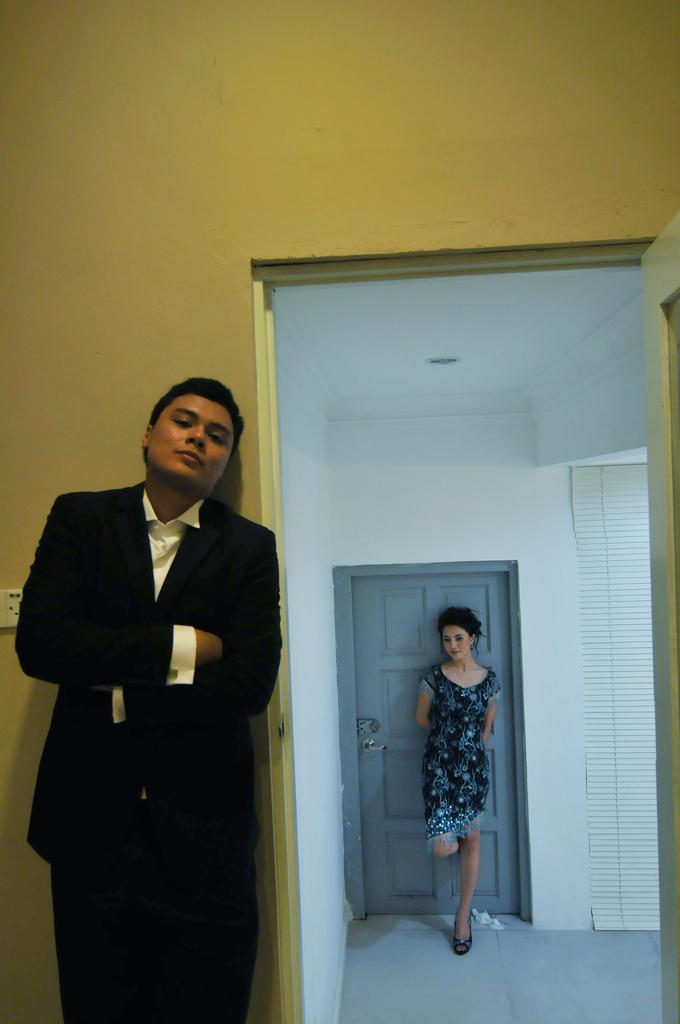Who is present in the image? There is a man and a girl in the image. What is the man wearing? The man is wearing a black suit. Where is the man standing? The man is standing in front. What is the girl wearing? The girl is wearing a black and grey top. Where is the girl standing? The girl is standing at a grey color door. What country is suggested by the clothing in the image? The clothing in the image does not suggest a specific country. How low is the girl standing in the image? The girl's height is not mentioned in the image, and her standing position does not indicate a specific height or low position. 